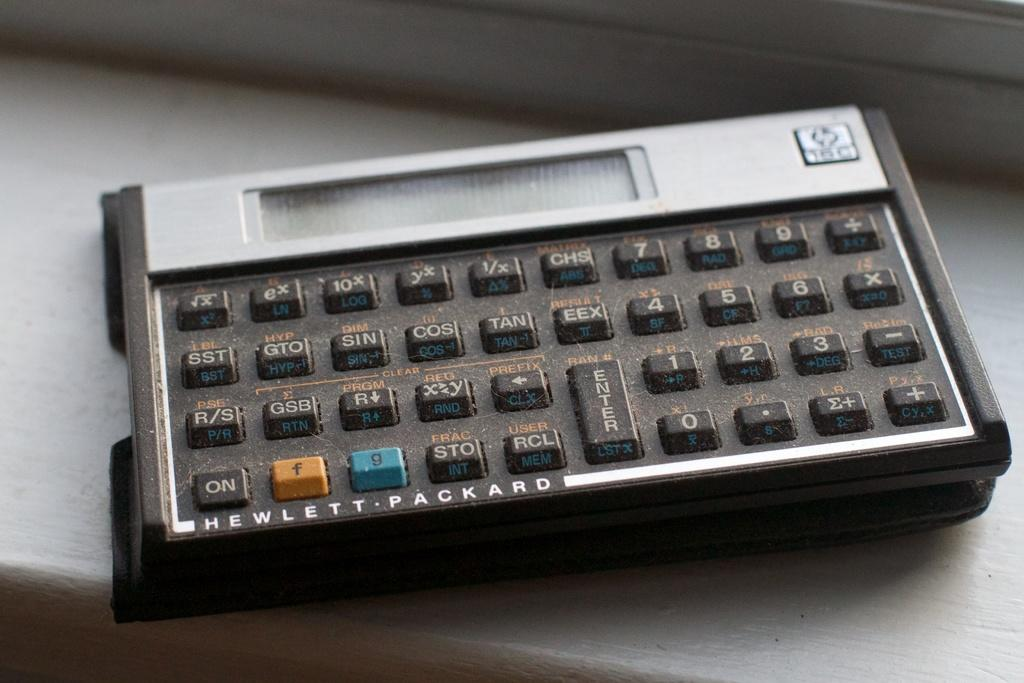<image>
Create a compact narrative representing the image presented. A Hewlett-Packard calculator is sitting on a ledge. 